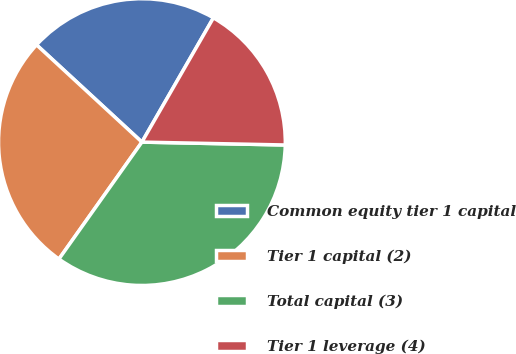<chart> <loc_0><loc_0><loc_500><loc_500><pie_chart><fcel>Common equity tier 1 capital<fcel>Tier 1 capital (2)<fcel>Total capital (3)<fcel>Tier 1 leverage (4)<nl><fcel>21.45%<fcel>27.04%<fcel>34.5%<fcel>17.01%<nl></chart> 